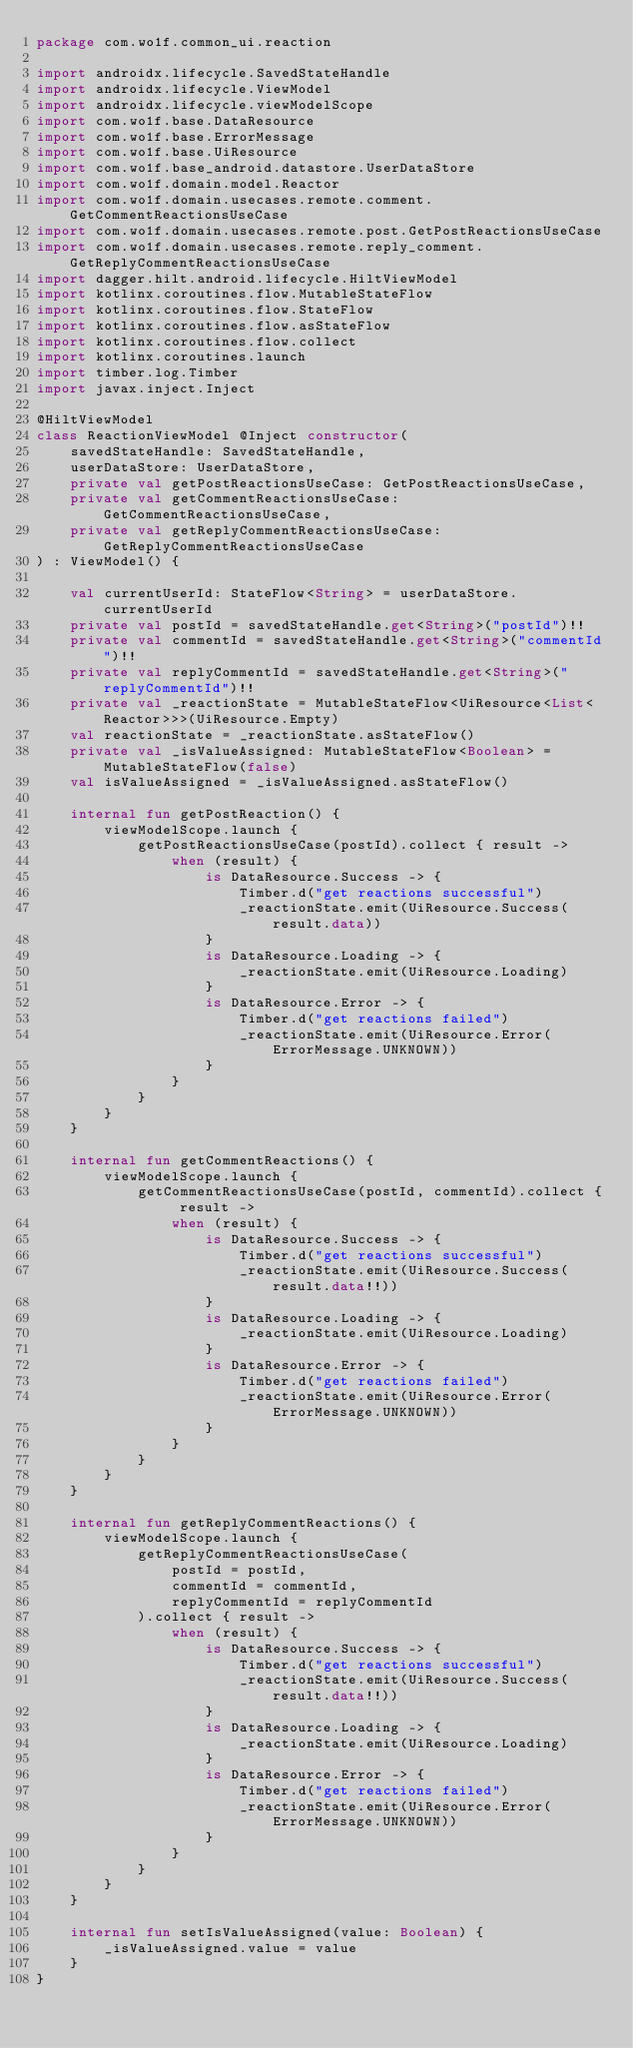<code> <loc_0><loc_0><loc_500><loc_500><_Kotlin_>package com.wo1f.common_ui.reaction

import androidx.lifecycle.SavedStateHandle
import androidx.lifecycle.ViewModel
import androidx.lifecycle.viewModelScope
import com.wo1f.base.DataResource
import com.wo1f.base.ErrorMessage
import com.wo1f.base.UiResource
import com.wo1f.base_android.datastore.UserDataStore
import com.wo1f.domain.model.Reactor
import com.wo1f.domain.usecases.remote.comment.GetCommentReactionsUseCase
import com.wo1f.domain.usecases.remote.post.GetPostReactionsUseCase
import com.wo1f.domain.usecases.remote.reply_comment.GetReplyCommentReactionsUseCase
import dagger.hilt.android.lifecycle.HiltViewModel
import kotlinx.coroutines.flow.MutableStateFlow
import kotlinx.coroutines.flow.StateFlow
import kotlinx.coroutines.flow.asStateFlow
import kotlinx.coroutines.flow.collect
import kotlinx.coroutines.launch
import timber.log.Timber
import javax.inject.Inject

@HiltViewModel
class ReactionViewModel @Inject constructor(
    savedStateHandle: SavedStateHandle,
    userDataStore: UserDataStore,
    private val getPostReactionsUseCase: GetPostReactionsUseCase,
    private val getCommentReactionsUseCase: GetCommentReactionsUseCase,
    private val getReplyCommentReactionsUseCase: GetReplyCommentReactionsUseCase
) : ViewModel() {

    val currentUserId: StateFlow<String> = userDataStore.currentUserId
    private val postId = savedStateHandle.get<String>("postId")!!
    private val commentId = savedStateHandle.get<String>("commentId")!!
    private val replyCommentId = savedStateHandle.get<String>("replyCommentId")!!
    private val _reactionState = MutableStateFlow<UiResource<List<Reactor>>>(UiResource.Empty)
    val reactionState = _reactionState.asStateFlow()
    private val _isValueAssigned: MutableStateFlow<Boolean> = MutableStateFlow(false)
    val isValueAssigned = _isValueAssigned.asStateFlow()

    internal fun getPostReaction() {
        viewModelScope.launch {
            getPostReactionsUseCase(postId).collect { result ->
                when (result) {
                    is DataResource.Success -> {
                        Timber.d("get reactions successful")
                        _reactionState.emit(UiResource.Success(result.data))
                    }
                    is DataResource.Loading -> {
                        _reactionState.emit(UiResource.Loading)
                    }
                    is DataResource.Error -> {
                        Timber.d("get reactions failed")
                        _reactionState.emit(UiResource.Error(ErrorMessage.UNKNOWN))
                    }
                }
            }
        }
    }

    internal fun getCommentReactions() {
        viewModelScope.launch {
            getCommentReactionsUseCase(postId, commentId).collect { result ->
                when (result) {
                    is DataResource.Success -> {
                        Timber.d("get reactions successful")
                        _reactionState.emit(UiResource.Success(result.data!!))
                    }
                    is DataResource.Loading -> {
                        _reactionState.emit(UiResource.Loading)
                    }
                    is DataResource.Error -> {
                        Timber.d("get reactions failed")
                        _reactionState.emit(UiResource.Error(ErrorMessage.UNKNOWN))
                    }
                }
            }
        }
    }

    internal fun getReplyCommentReactions() {
        viewModelScope.launch {
            getReplyCommentReactionsUseCase(
                postId = postId,
                commentId = commentId,
                replyCommentId = replyCommentId
            ).collect { result ->
                when (result) {
                    is DataResource.Success -> {
                        Timber.d("get reactions successful")
                        _reactionState.emit(UiResource.Success(result.data!!))
                    }
                    is DataResource.Loading -> {
                        _reactionState.emit(UiResource.Loading)
                    }
                    is DataResource.Error -> {
                        Timber.d("get reactions failed")
                        _reactionState.emit(UiResource.Error(ErrorMessage.UNKNOWN))
                    }
                }
            }
        }
    }

    internal fun setIsValueAssigned(value: Boolean) {
        _isValueAssigned.value = value
    }
}
</code> 